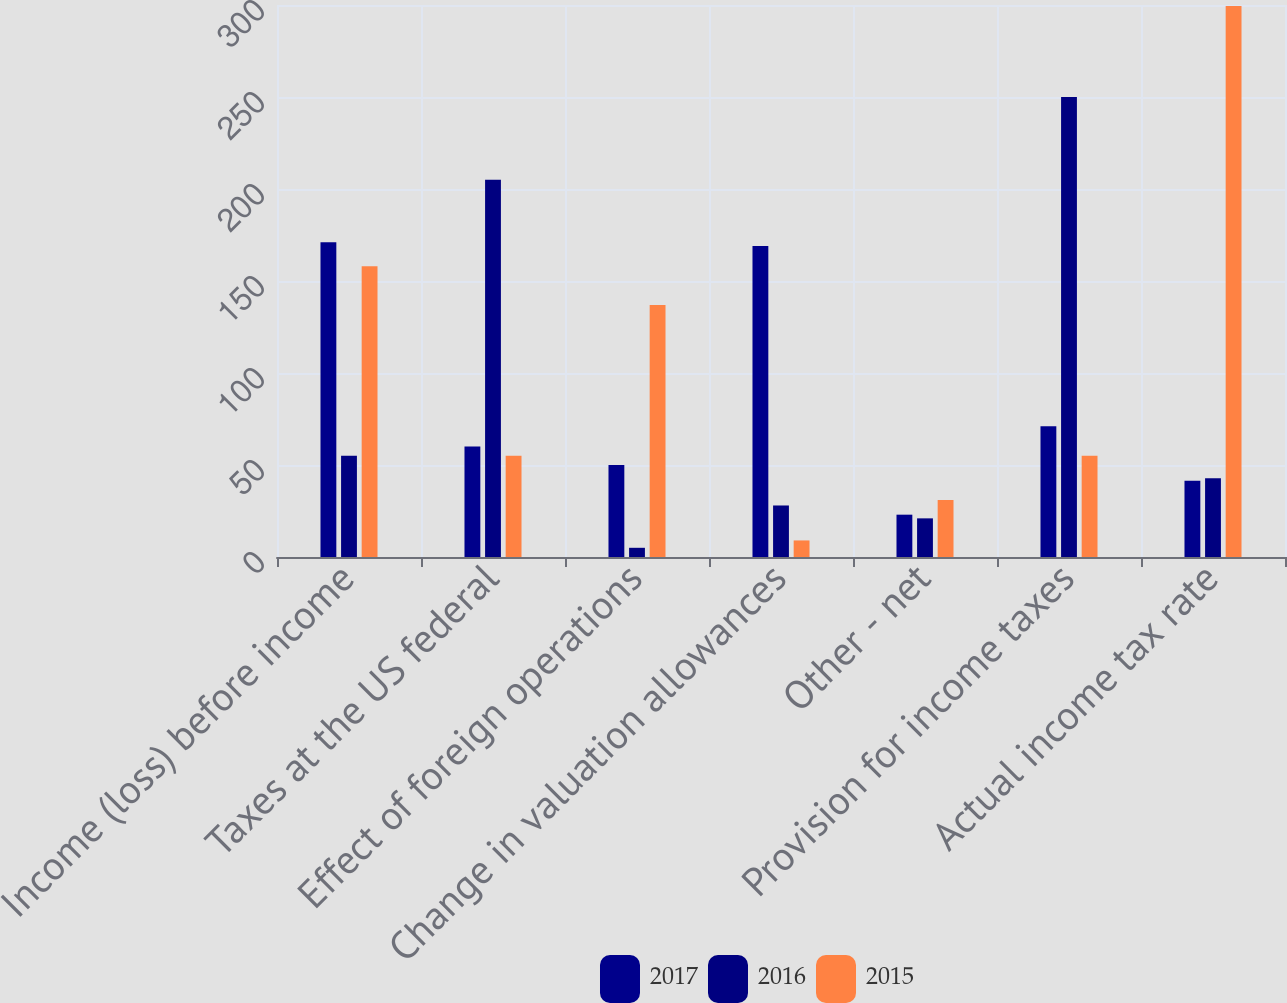Convert chart to OTSL. <chart><loc_0><loc_0><loc_500><loc_500><stacked_bar_chart><ecel><fcel>Income (loss) before income<fcel>Taxes at the US federal<fcel>Effect of foreign operations<fcel>Change in valuation allowances<fcel>Other - net<fcel>Provision for income taxes<fcel>Actual income tax rate<nl><fcel>2017<fcel>171<fcel>60<fcel>50<fcel>169<fcel>23<fcel>71<fcel>41.5<nl><fcel>2016<fcel>55<fcel>205<fcel>5<fcel>28<fcel>21<fcel>250<fcel>42.8<nl><fcel>2015<fcel>158<fcel>55<fcel>137<fcel>9<fcel>31<fcel>55<fcel>299.4<nl></chart> 